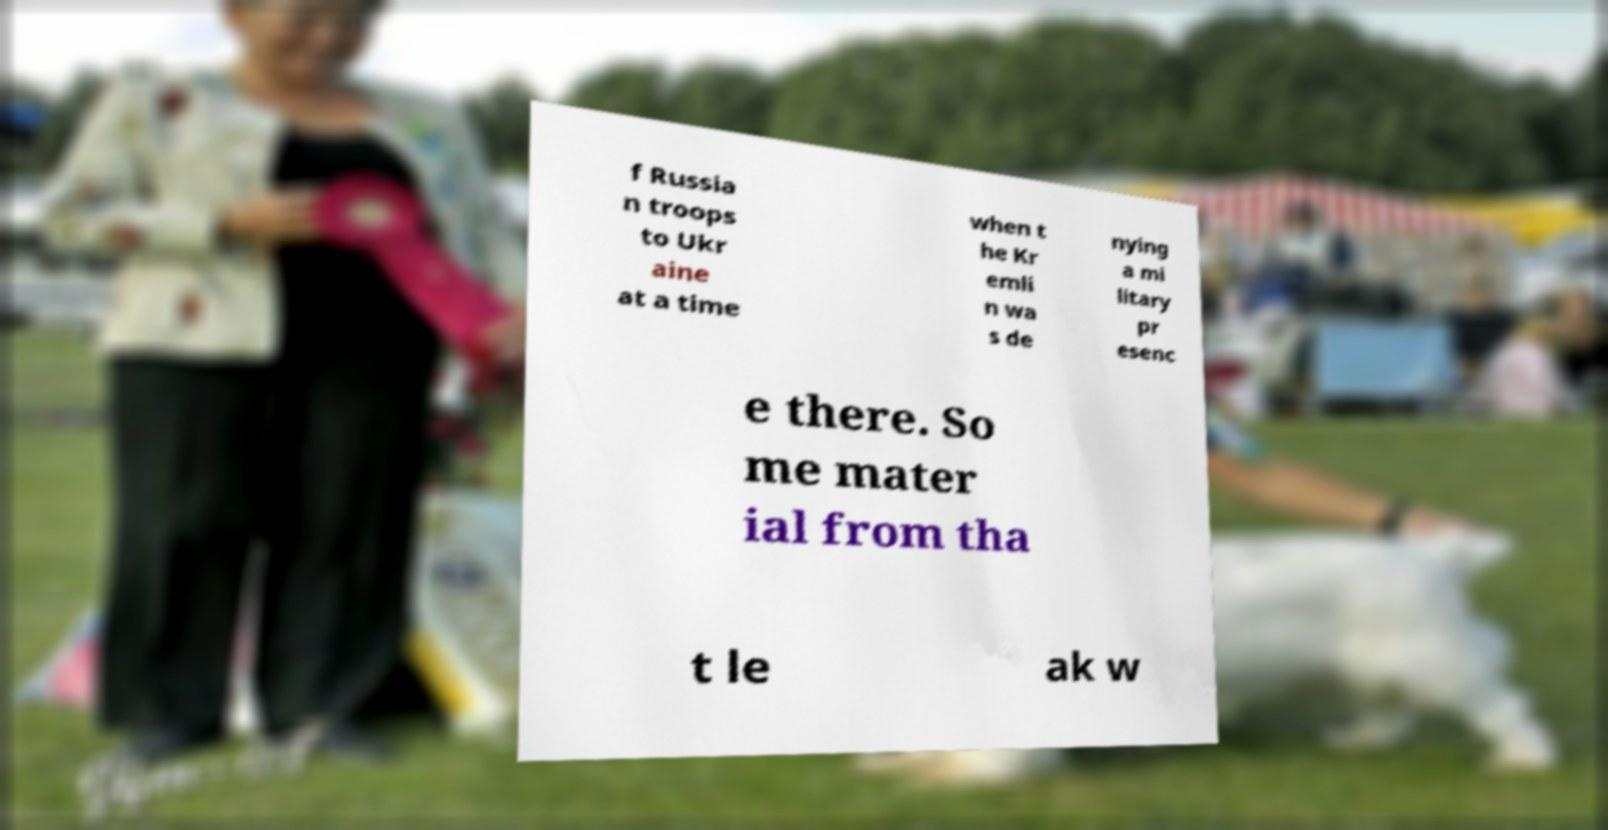What messages or text are displayed in this image? I need them in a readable, typed format. f Russia n troops to Ukr aine at a time when t he Kr emli n wa s de nying a mi litary pr esenc e there. So me mater ial from tha t le ak w 